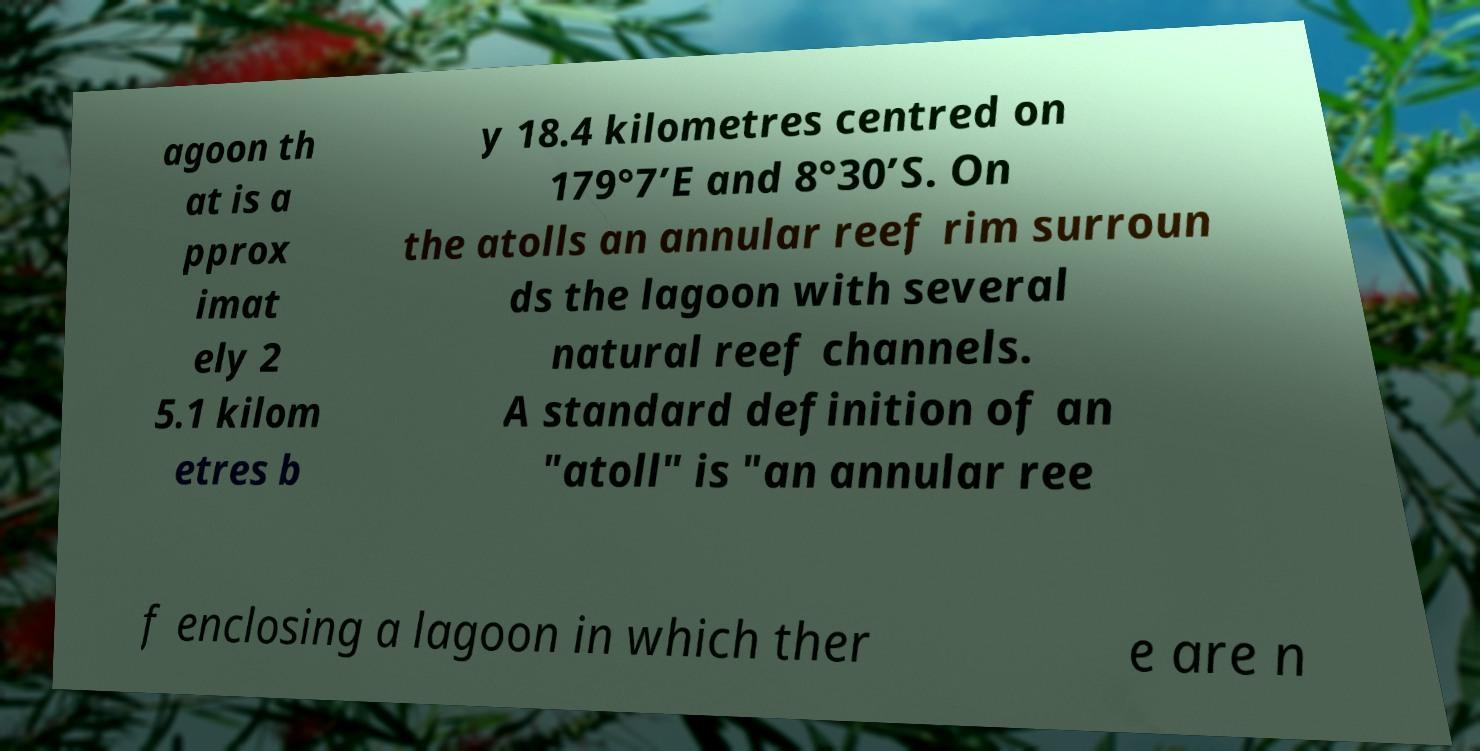Can you accurately transcribe the text from the provided image for me? agoon th at is a pprox imat ely 2 5.1 kilom etres b y 18.4 kilometres centred on 179°7’E and 8°30’S. On the atolls an annular reef rim surroun ds the lagoon with several natural reef channels. A standard definition of an "atoll" is "an annular ree f enclosing a lagoon in which ther e are n 